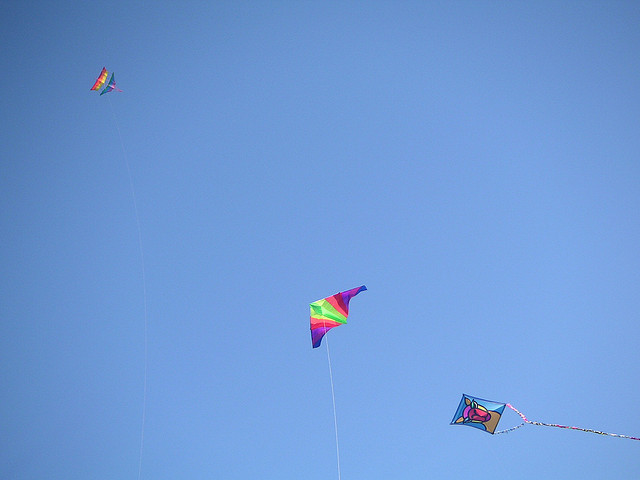<image>Is there any kind of building visible? There is no building visible in the image. Is there any kind of building visible? There is no building visible in the image. 